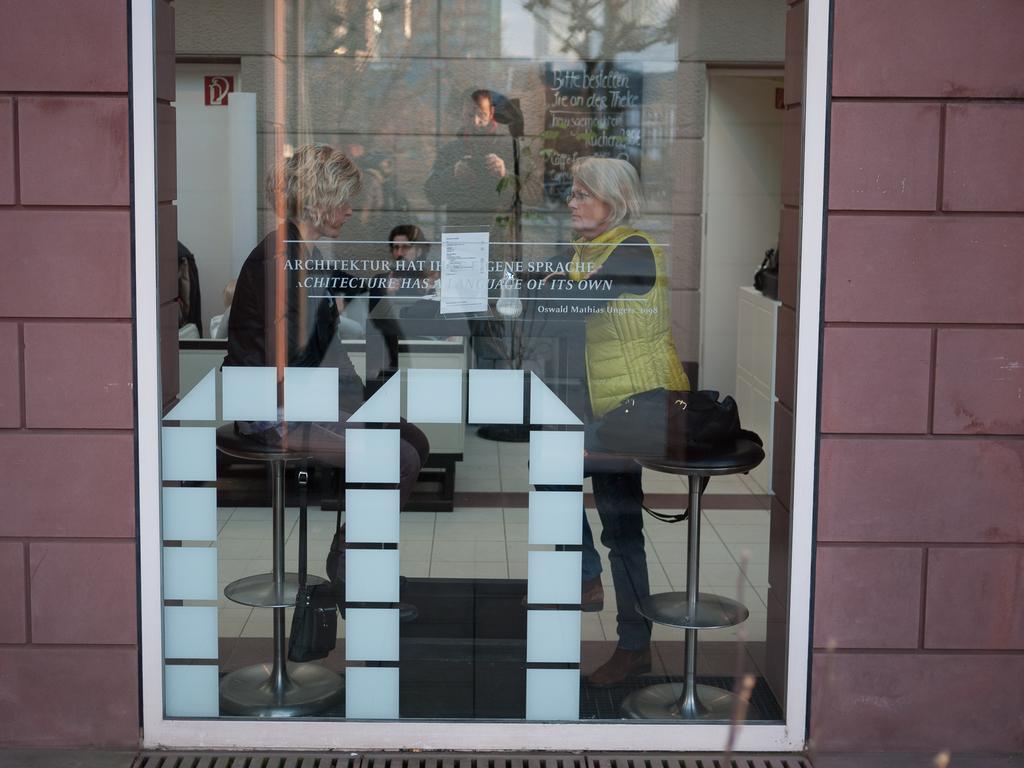Could you give a brief overview of what you see in this image? In this image we can see there is a wall and window, through the window we can see there are people sitting on the chair and at the back there is a poster and a text written. And there are some objects. 